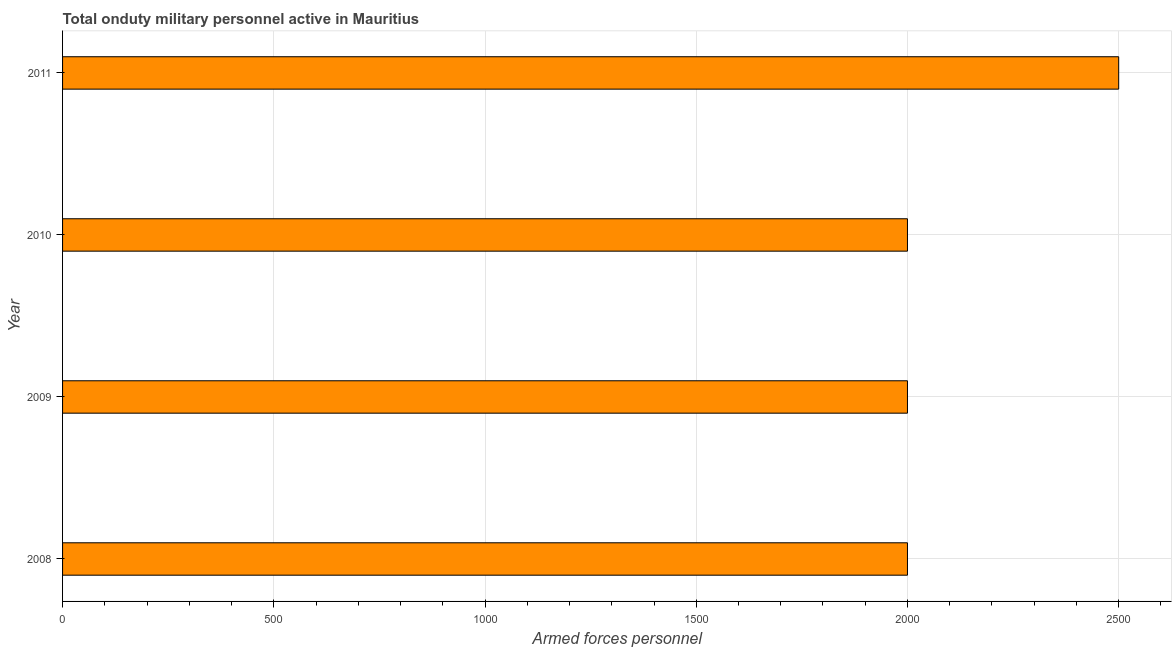Does the graph contain any zero values?
Keep it short and to the point. No. What is the title of the graph?
Offer a terse response. Total onduty military personnel active in Mauritius. What is the label or title of the X-axis?
Keep it short and to the point. Armed forces personnel. What is the label or title of the Y-axis?
Make the answer very short. Year. What is the number of armed forces personnel in 2009?
Offer a terse response. 2000. Across all years, what is the maximum number of armed forces personnel?
Your answer should be compact. 2500. Across all years, what is the minimum number of armed forces personnel?
Your response must be concise. 2000. In which year was the number of armed forces personnel maximum?
Make the answer very short. 2011. What is the sum of the number of armed forces personnel?
Your answer should be very brief. 8500. What is the difference between the number of armed forces personnel in 2008 and 2011?
Your answer should be very brief. -500. What is the average number of armed forces personnel per year?
Offer a terse response. 2125. In how many years, is the number of armed forces personnel greater than 700 ?
Give a very brief answer. 4. Do a majority of the years between 2009 and 2010 (inclusive) have number of armed forces personnel greater than 2300 ?
Keep it short and to the point. No. Is the number of armed forces personnel in 2008 less than that in 2011?
Offer a very short reply. Yes. Is the difference between the number of armed forces personnel in 2010 and 2011 greater than the difference between any two years?
Keep it short and to the point. Yes. What is the difference between the highest and the second highest number of armed forces personnel?
Give a very brief answer. 500. In how many years, is the number of armed forces personnel greater than the average number of armed forces personnel taken over all years?
Your answer should be compact. 1. Are all the bars in the graph horizontal?
Keep it short and to the point. Yes. What is the difference between two consecutive major ticks on the X-axis?
Make the answer very short. 500. What is the Armed forces personnel in 2008?
Give a very brief answer. 2000. What is the Armed forces personnel of 2011?
Provide a succinct answer. 2500. What is the difference between the Armed forces personnel in 2008 and 2011?
Your response must be concise. -500. What is the difference between the Armed forces personnel in 2009 and 2011?
Offer a terse response. -500. What is the difference between the Armed forces personnel in 2010 and 2011?
Make the answer very short. -500. What is the ratio of the Armed forces personnel in 2008 to that in 2009?
Your answer should be very brief. 1. What is the ratio of the Armed forces personnel in 2008 to that in 2010?
Keep it short and to the point. 1. What is the ratio of the Armed forces personnel in 2009 to that in 2010?
Provide a short and direct response. 1. What is the ratio of the Armed forces personnel in 2009 to that in 2011?
Provide a succinct answer. 0.8. 